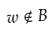<formula> <loc_0><loc_0><loc_500><loc_500>w \notin B</formula> 